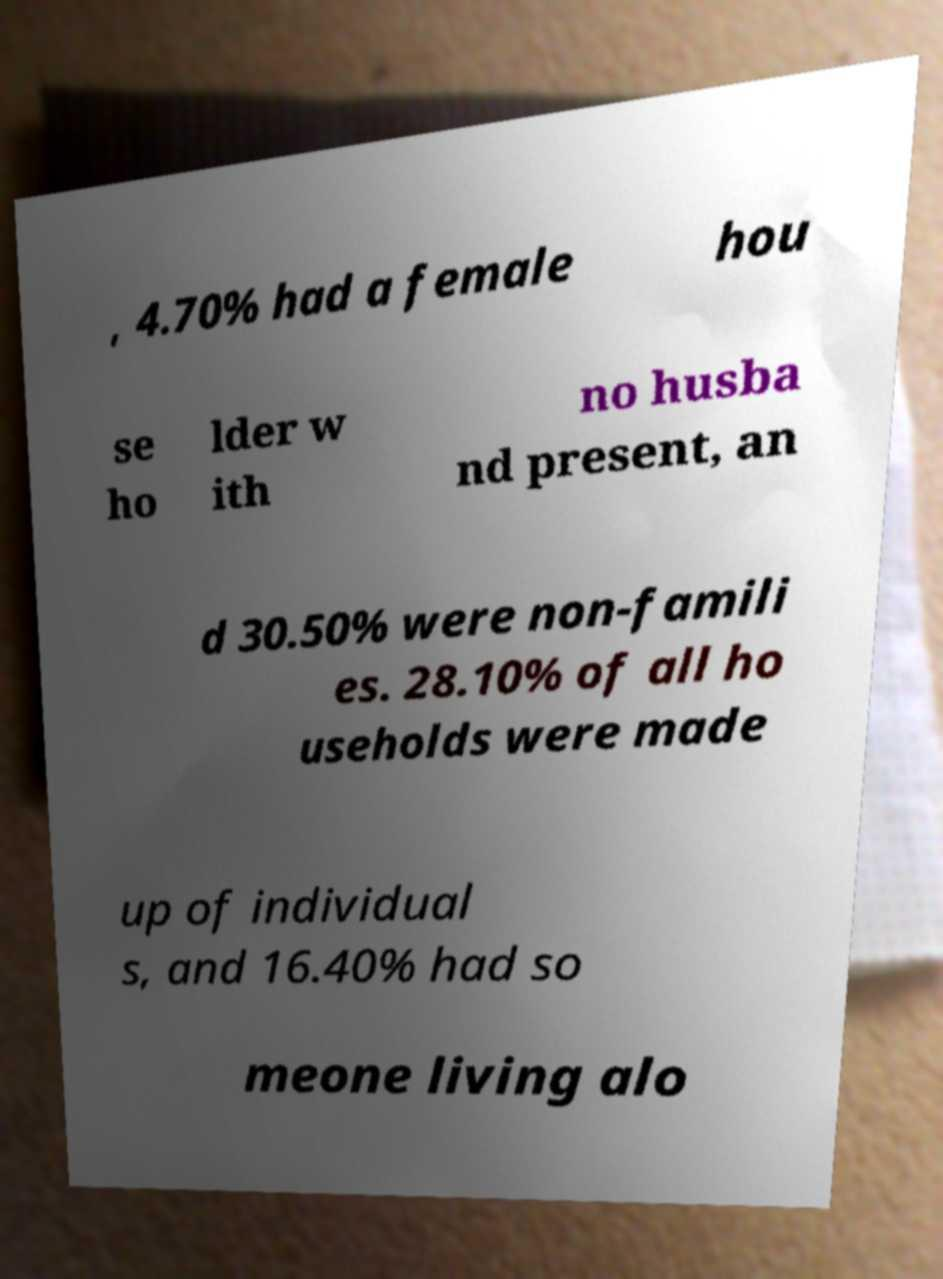There's text embedded in this image that I need extracted. Can you transcribe it verbatim? , 4.70% had a female hou se ho lder w ith no husba nd present, an d 30.50% were non-famili es. 28.10% of all ho useholds were made up of individual s, and 16.40% had so meone living alo 